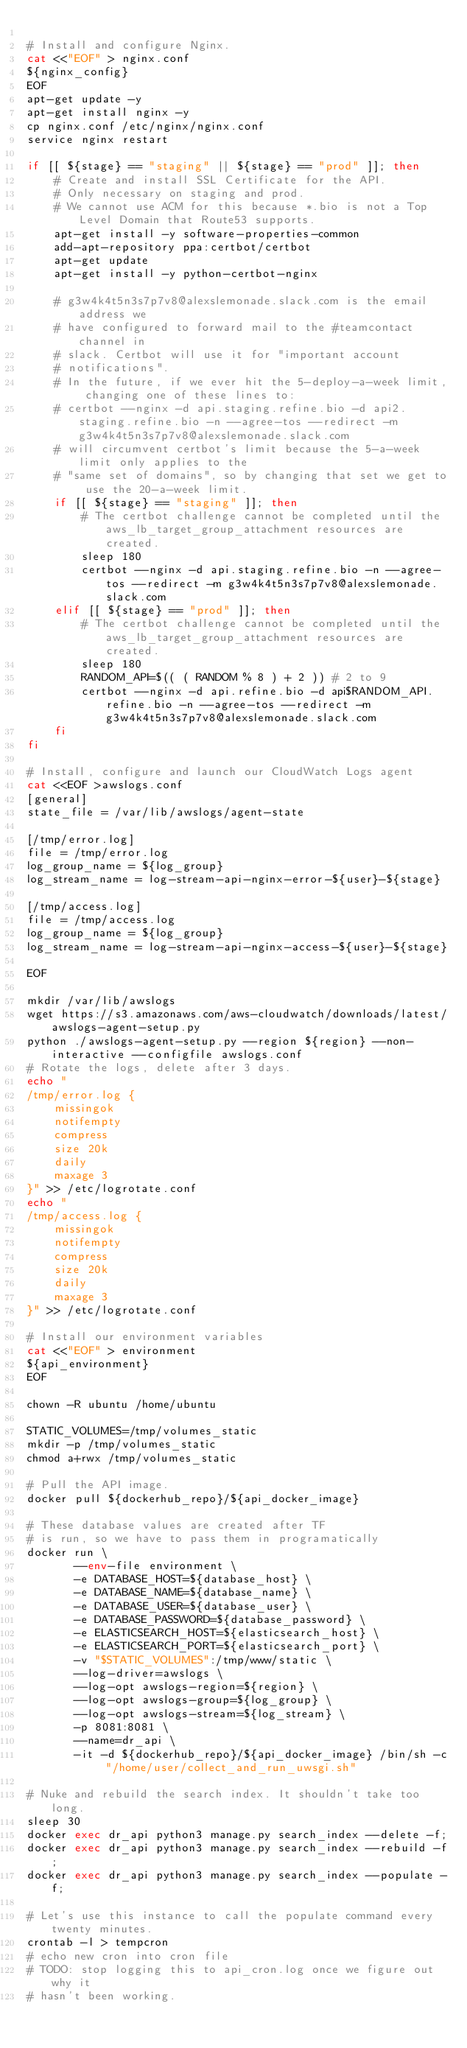Convert code to text. <code><loc_0><loc_0><loc_500><loc_500><_Bash_>
# Install and configure Nginx.
cat <<"EOF" > nginx.conf
${nginx_config}
EOF
apt-get update -y
apt-get install nginx -y
cp nginx.conf /etc/nginx/nginx.conf
service nginx restart

if [[ ${stage} == "staging" || ${stage} == "prod" ]]; then
    # Create and install SSL Certificate for the API.
    # Only necessary on staging and prod.
    # We cannot use ACM for this because *.bio is not a Top Level Domain that Route53 supports.
    apt-get install -y software-properties-common
    add-apt-repository ppa:certbot/certbot
    apt-get update
    apt-get install -y python-certbot-nginx

    # g3w4k4t5n3s7p7v8@alexslemonade.slack.com is the email address we
    # have configured to forward mail to the #teamcontact channel in
    # slack. Certbot will use it for "important account
    # notifications".
    # In the future, if we ever hit the 5-deploy-a-week limit, changing one of these lines to:
    # certbot --nginx -d api.staging.refine.bio -d api2.staging.refine.bio -n --agree-tos --redirect -m g3w4k4t5n3s7p7v8@alexslemonade.slack.com
    # will circumvent certbot's limit because the 5-a-week limit only applies to the
    # "same set of domains", so by changing that set we get to use the 20-a-week limit.
    if [[ ${stage} == "staging" ]]; then
        # The certbot challenge cannot be completed until the aws_lb_target_group_attachment resources are created.
        sleep 180
        certbot --nginx -d api.staging.refine.bio -n --agree-tos --redirect -m g3w4k4t5n3s7p7v8@alexslemonade.slack.com
    elif [[ ${stage} == "prod" ]]; then
        # The certbot challenge cannot be completed until the aws_lb_target_group_attachment resources are created.
        sleep 180
        RANDOM_API=$(( ( RANDOM % 8 ) + 2 )) # 2 to 9
        certbot --nginx -d api.refine.bio -d api$RANDOM_API.refine.bio -n --agree-tos --redirect -m g3w4k4t5n3s7p7v8@alexslemonade.slack.com
    fi
fi

# Install, configure and launch our CloudWatch Logs agent
cat <<EOF >awslogs.conf
[general]
state_file = /var/lib/awslogs/agent-state

[/tmp/error.log]
file = /tmp/error.log
log_group_name = ${log_group}
log_stream_name = log-stream-api-nginx-error-${user}-${stage}

[/tmp/access.log]
file = /tmp/access.log
log_group_name = ${log_group}
log_stream_name = log-stream-api-nginx-access-${user}-${stage}

EOF

mkdir /var/lib/awslogs
wget https://s3.amazonaws.com/aws-cloudwatch/downloads/latest/awslogs-agent-setup.py
python ./awslogs-agent-setup.py --region ${region} --non-interactive --configfile awslogs.conf
# Rotate the logs, delete after 3 days.
echo "
/tmp/error.log {
    missingok
    notifempty
    compress
    size 20k
    daily
    maxage 3
}" >> /etc/logrotate.conf
echo "
/tmp/access.log {
    missingok
    notifempty
    compress
    size 20k
    daily
    maxage 3
}" >> /etc/logrotate.conf

# Install our environment variables
cat <<"EOF" > environment
${api_environment}
EOF

chown -R ubuntu /home/ubuntu

STATIC_VOLUMES=/tmp/volumes_static
mkdir -p /tmp/volumes_static
chmod a+rwx /tmp/volumes_static

# Pull the API image.
docker pull ${dockerhub_repo}/${api_docker_image}

# These database values are created after TF
# is run, so we have to pass them in programatically
docker run \
       --env-file environment \
       -e DATABASE_HOST=${database_host} \
       -e DATABASE_NAME=${database_name} \
       -e DATABASE_USER=${database_user} \
       -e DATABASE_PASSWORD=${database_password} \
       -e ELASTICSEARCH_HOST=${elasticsearch_host} \
       -e ELASTICSEARCH_PORT=${elasticsearch_port} \
       -v "$STATIC_VOLUMES":/tmp/www/static \
       --log-driver=awslogs \
       --log-opt awslogs-region=${region} \
       --log-opt awslogs-group=${log_group} \
       --log-opt awslogs-stream=${log_stream} \
       -p 8081:8081 \
       --name=dr_api \
       -it -d ${dockerhub_repo}/${api_docker_image} /bin/sh -c "/home/user/collect_and_run_uwsgi.sh"

# Nuke and rebuild the search index. It shouldn't take too long.
sleep 30
docker exec dr_api python3 manage.py search_index --delete -f;
docker exec dr_api python3 manage.py search_index --rebuild -f;
docker exec dr_api python3 manage.py search_index --populate -f;

# Let's use this instance to call the populate command every twenty minutes.
crontab -l > tempcron
# echo new cron into cron file
# TODO: stop logging this to api_cron.log once we figure out why it
# hasn't been working.</code> 